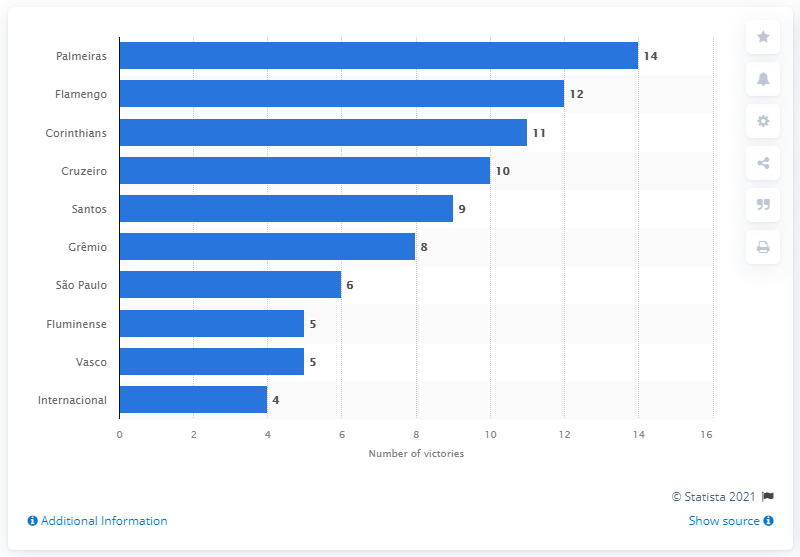Mention a couple of crucial points in this snapshot. Flamengo won the Campeonato Brasileiro Série A in 2020, becoming the champion of the Brazilian soccer league. The soccer club, Palmeiras, has won the Campeonato Brasileiro Série A a record 14 times as of 2020. 